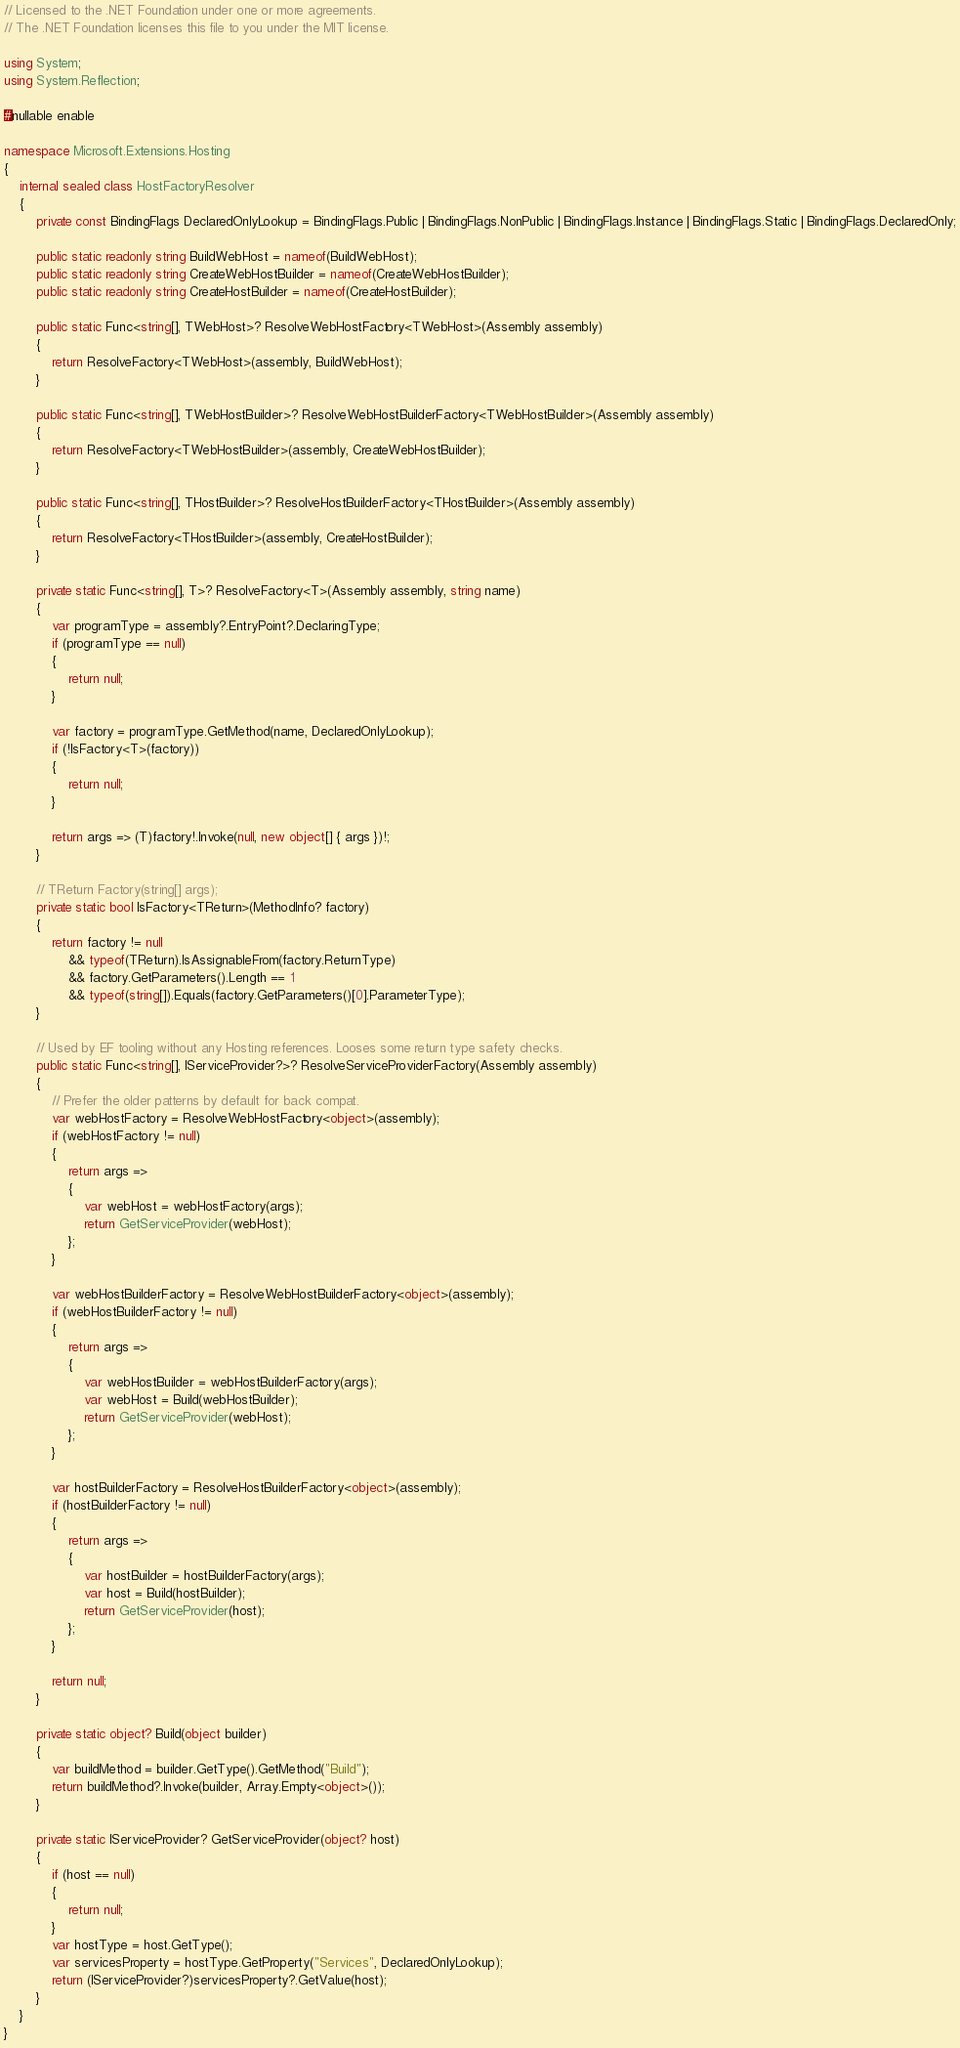<code> <loc_0><loc_0><loc_500><loc_500><_C#_>// Licensed to the .NET Foundation under one or more agreements.
// The .NET Foundation licenses this file to you under the MIT license.

using System;
using System.Reflection;

#nullable enable

namespace Microsoft.Extensions.Hosting
{
    internal sealed class HostFactoryResolver
    {
        private const BindingFlags DeclaredOnlyLookup = BindingFlags.Public | BindingFlags.NonPublic | BindingFlags.Instance | BindingFlags.Static | BindingFlags.DeclaredOnly;

        public static readonly string BuildWebHost = nameof(BuildWebHost);
        public static readonly string CreateWebHostBuilder = nameof(CreateWebHostBuilder);
        public static readonly string CreateHostBuilder = nameof(CreateHostBuilder);

        public static Func<string[], TWebHost>? ResolveWebHostFactory<TWebHost>(Assembly assembly)
        {
            return ResolveFactory<TWebHost>(assembly, BuildWebHost);
        }

        public static Func<string[], TWebHostBuilder>? ResolveWebHostBuilderFactory<TWebHostBuilder>(Assembly assembly)
        {
            return ResolveFactory<TWebHostBuilder>(assembly, CreateWebHostBuilder);
        }

        public static Func<string[], THostBuilder>? ResolveHostBuilderFactory<THostBuilder>(Assembly assembly)
        {
            return ResolveFactory<THostBuilder>(assembly, CreateHostBuilder);
        }

        private static Func<string[], T>? ResolveFactory<T>(Assembly assembly, string name)
        {
            var programType = assembly?.EntryPoint?.DeclaringType;
            if (programType == null)
            {
                return null;
            }

            var factory = programType.GetMethod(name, DeclaredOnlyLookup);
            if (!IsFactory<T>(factory))
            {
                return null;
            }

            return args => (T)factory!.Invoke(null, new object[] { args })!;
        }

        // TReturn Factory(string[] args);
        private static bool IsFactory<TReturn>(MethodInfo? factory)
        {
            return factory != null
                && typeof(TReturn).IsAssignableFrom(factory.ReturnType)
                && factory.GetParameters().Length == 1
                && typeof(string[]).Equals(factory.GetParameters()[0].ParameterType);
        }

        // Used by EF tooling without any Hosting references. Looses some return type safety checks.
        public static Func<string[], IServiceProvider?>? ResolveServiceProviderFactory(Assembly assembly)
        {
            // Prefer the older patterns by default for back compat.
            var webHostFactory = ResolveWebHostFactory<object>(assembly);
            if (webHostFactory != null)
            {
                return args =>
                {
                    var webHost = webHostFactory(args);
                    return GetServiceProvider(webHost);
                };
            }

            var webHostBuilderFactory = ResolveWebHostBuilderFactory<object>(assembly);
            if (webHostBuilderFactory != null)
            {
                return args =>
                {
                    var webHostBuilder = webHostBuilderFactory(args);
                    var webHost = Build(webHostBuilder);
                    return GetServiceProvider(webHost);
                };
            }

            var hostBuilderFactory = ResolveHostBuilderFactory<object>(assembly);
            if (hostBuilderFactory != null)
            {
                return args =>
                {
                    var hostBuilder = hostBuilderFactory(args);
                    var host = Build(hostBuilder);
                    return GetServiceProvider(host);
                };
            }

            return null;
        }

        private static object? Build(object builder)
        {
            var buildMethod = builder.GetType().GetMethod("Build");
            return buildMethod?.Invoke(builder, Array.Empty<object>());
        }

        private static IServiceProvider? GetServiceProvider(object? host)
        {
            if (host == null)
            {
                return null;
            }
            var hostType = host.GetType();
            var servicesProperty = hostType.GetProperty("Services", DeclaredOnlyLookup);
            return (IServiceProvider?)servicesProperty?.GetValue(host);
        }
    }
}
</code> 